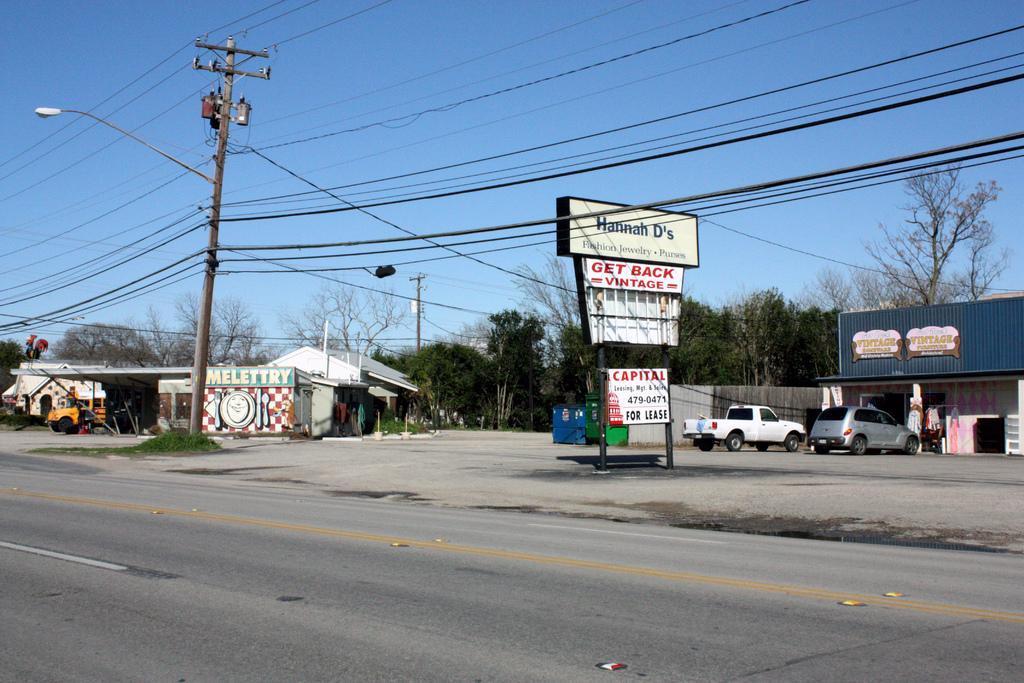Can you describe this image briefly? In this image we can see the road. And we can see the electrical poles, cables and street lights. And we can see the sheds and vehicles. And we can see the trees and sky. And we can see boards with some text on it. 